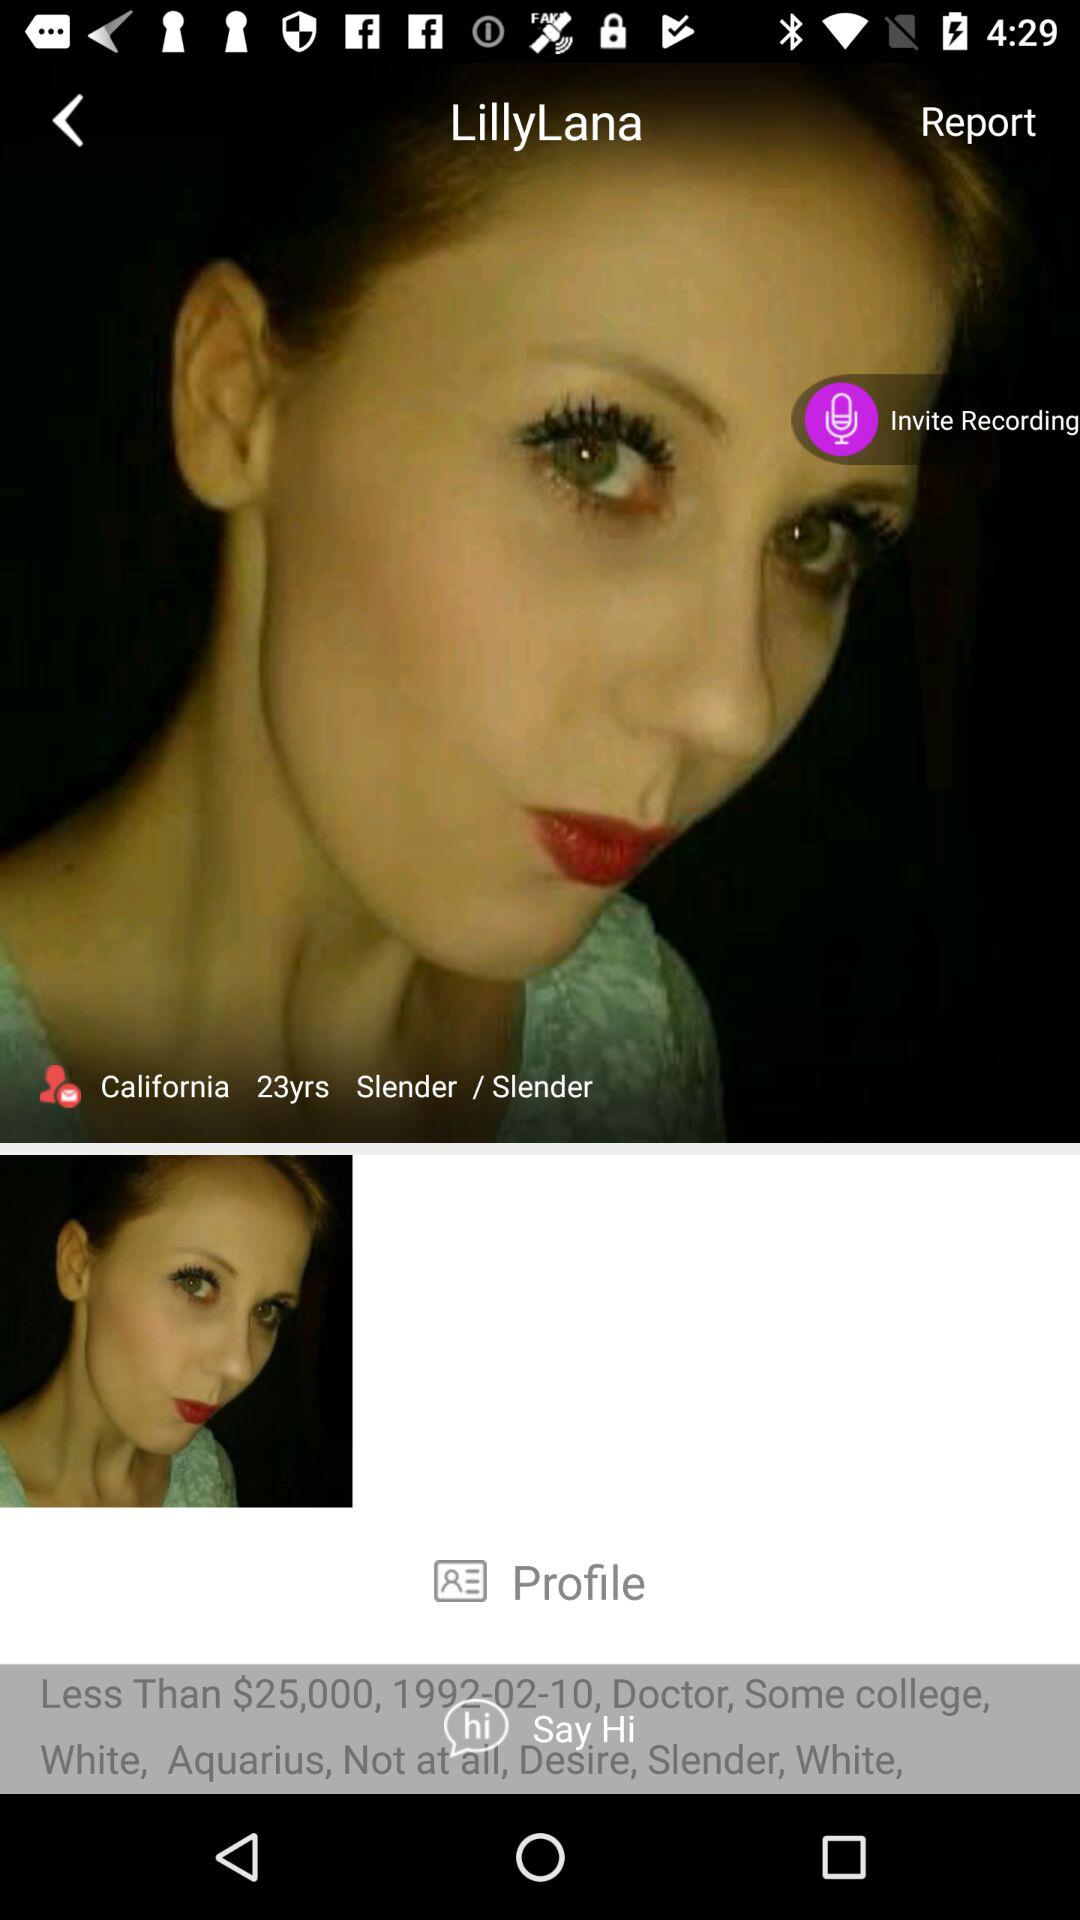Where did the user live? The user lived in California. 